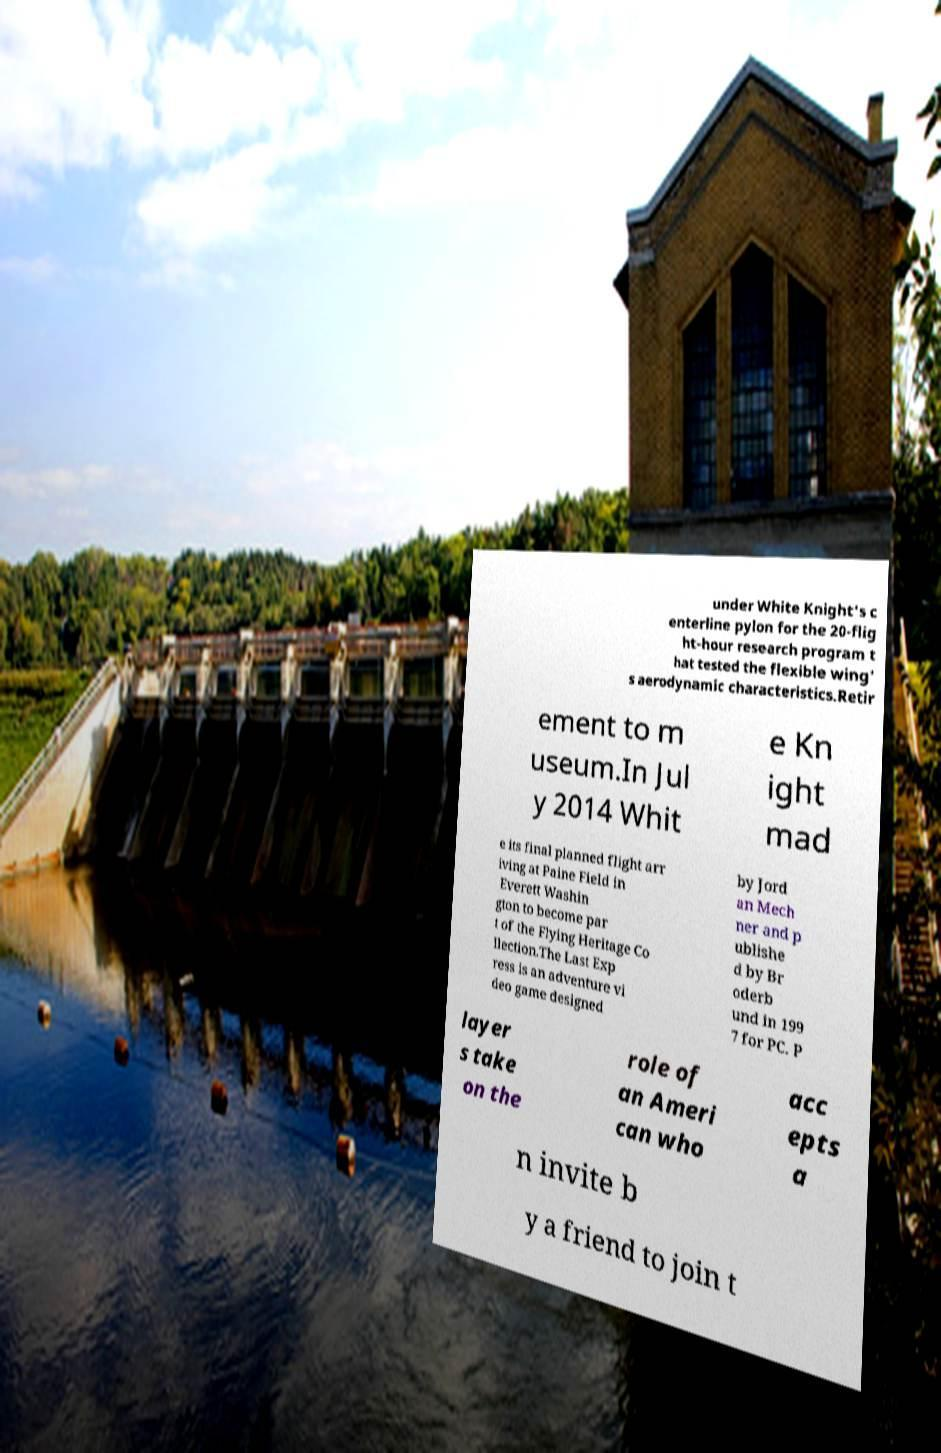Could you assist in decoding the text presented in this image and type it out clearly? under White Knight's c enterline pylon for the 20-flig ht-hour research program t hat tested the flexible wing' s aerodynamic characteristics.Retir ement to m useum.In Jul y 2014 Whit e Kn ight mad e its final planned flight arr iving at Paine Field in Everett Washin gton to become par t of the Flying Heritage Co llection.The Last Exp ress is an adventure vi deo game designed by Jord an Mech ner and p ublishe d by Br oderb und in 199 7 for PC. P layer s take on the role of an Ameri can who acc epts a n invite b y a friend to join t 